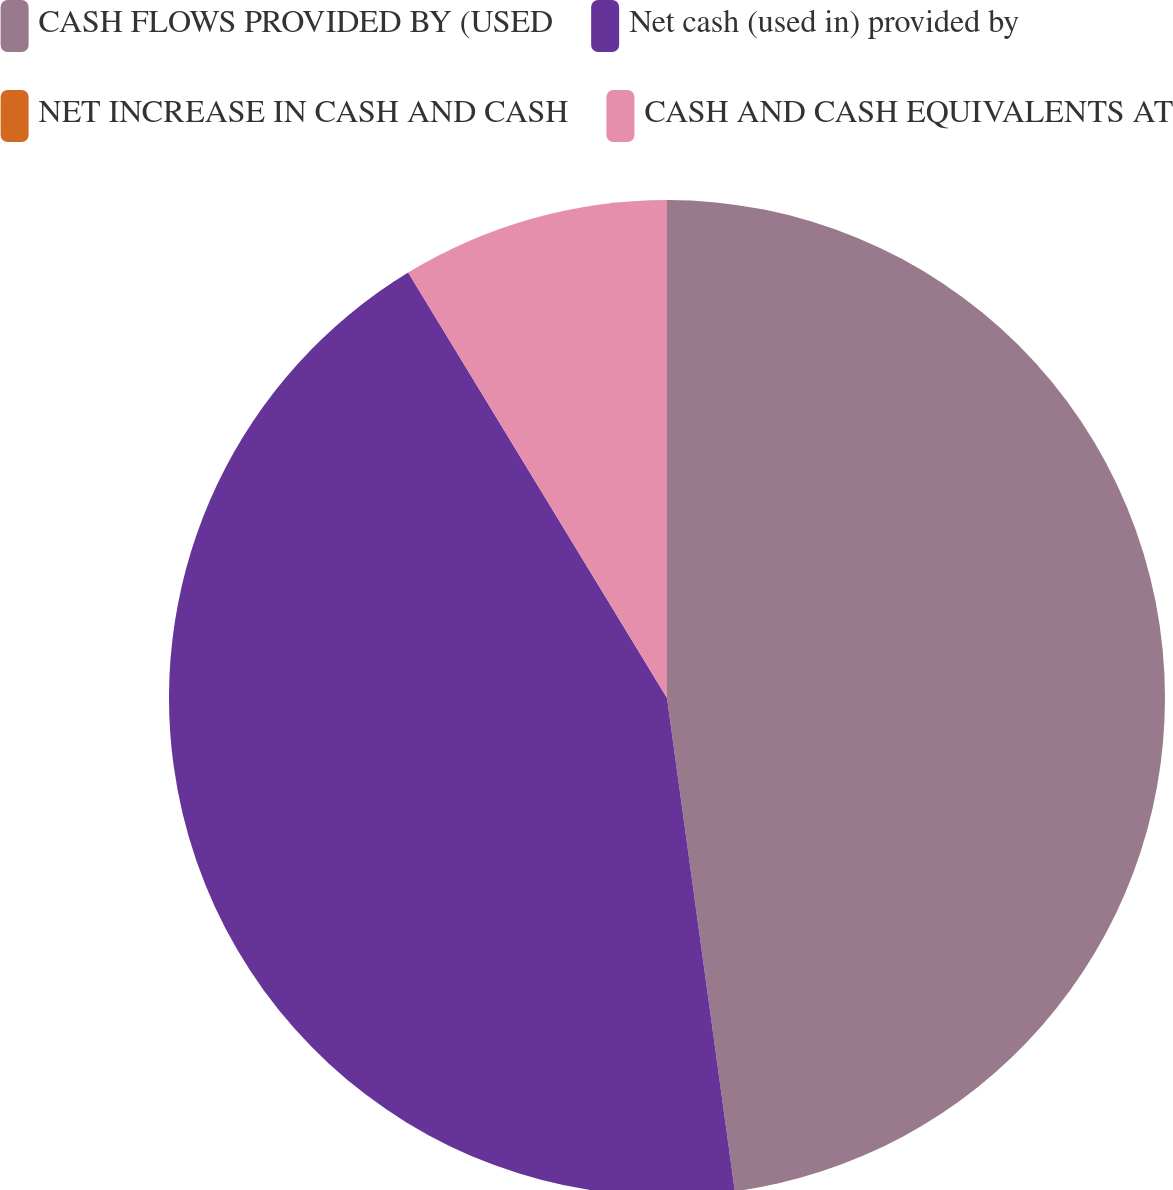<chart> <loc_0><loc_0><loc_500><loc_500><pie_chart><fcel>CASH FLOWS PROVIDED BY (USED<fcel>Net cash (used in) provided by<fcel>NET INCREASE IN CASH AND CASH<fcel>CASH AND CASH EQUIVALENTS AT<nl><fcel>47.83%<fcel>43.48%<fcel>0.0%<fcel>8.7%<nl></chart> 